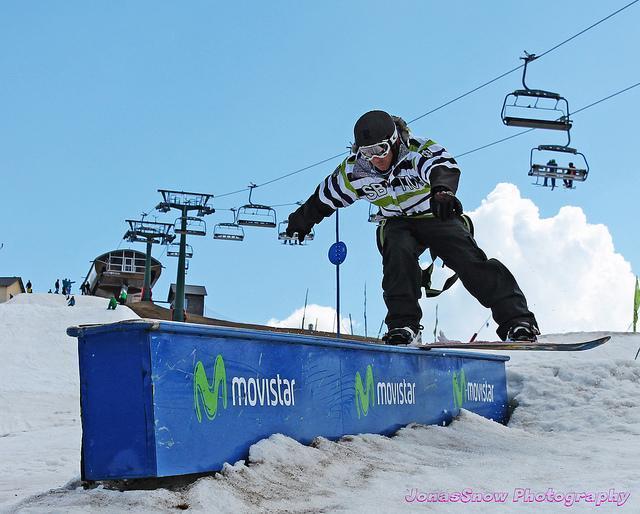How many motorcycles are on the truck?
Give a very brief answer. 0. 